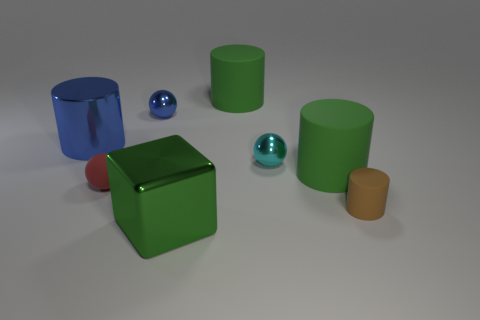There is a green cylinder in front of the green matte cylinder left of the large matte cylinder that is in front of the tiny blue metallic object; what is its material?
Your response must be concise. Rubber. Does the big blue metallic thing have the same shape as the large green metal thing?
Offer a terse response. No. There is a tiny brown thing that is the same shape as the large blue metal object; what material is it?
Give a very brief answer. Rubber. What number of tiny rubber cylinders have the same color as the cube?
Keep it short and to the point. 0. There is a brown cylinder that is made of the same material as the tiny red object; what is its size?
Keep it short and to the point. Small. What number of green things are large shiny cubes or shiny cylinders?
Give a very brief answer. 1. What number of tiny objects are in front of the small shiny object that is on the left side of the big metallic cube?
Make the answer very short. 3. Is the number of green shiny things behind the green shiny object greater than the number of blue objects in front of the small cyan metal object?
Provide a succinct answer. No. What material is the small red ball?
Offer a terse response. Rubber. Are there any green metallic objects of the same size as the shiny cylinder?
Offer a very short reply. Yes. 